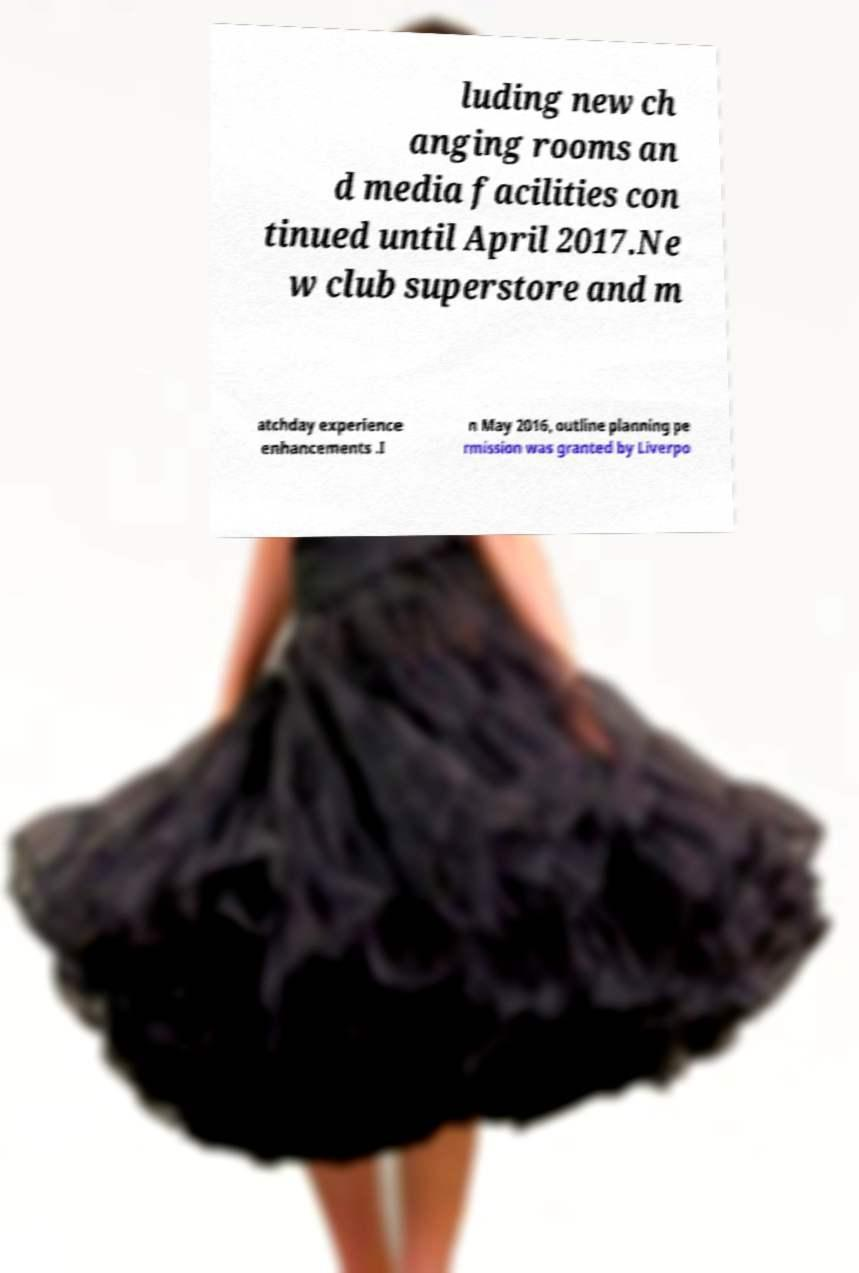For documentation purposes, I need the text within this image transcribed. Could you provide that? luding new ch anging rooms an d media facilities con tinued until April 2017.Ne w club superstore and m atchday experience enhancements .I n May 2016, outline planning pe rmission was granted by Liverpo 